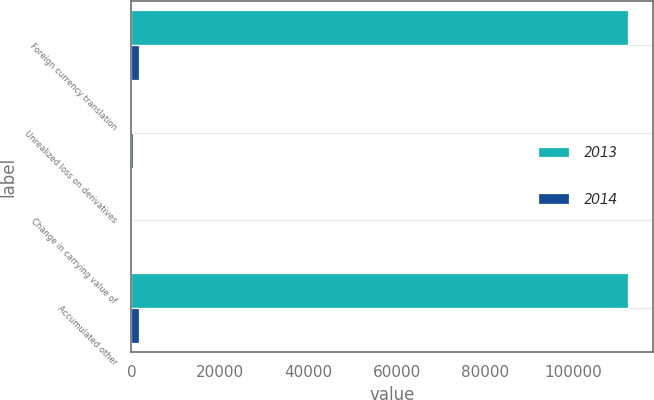<chart> <loc_0><loc_0><loc_500><loc_500><stacked_bar_chart><ecel><fcel>Foreign currency translation<fcel>Unrealized loss on derivatives<fcel>Change in carrying value of<fcel>Accumulated other<nl><fcel>2013<fcel>112411<fcel>84<fcel>232<fcel>112263<nl><fcel>2014<fcel>1677<fcel>256<fcel>232<fcel>1701<nl></chart> 